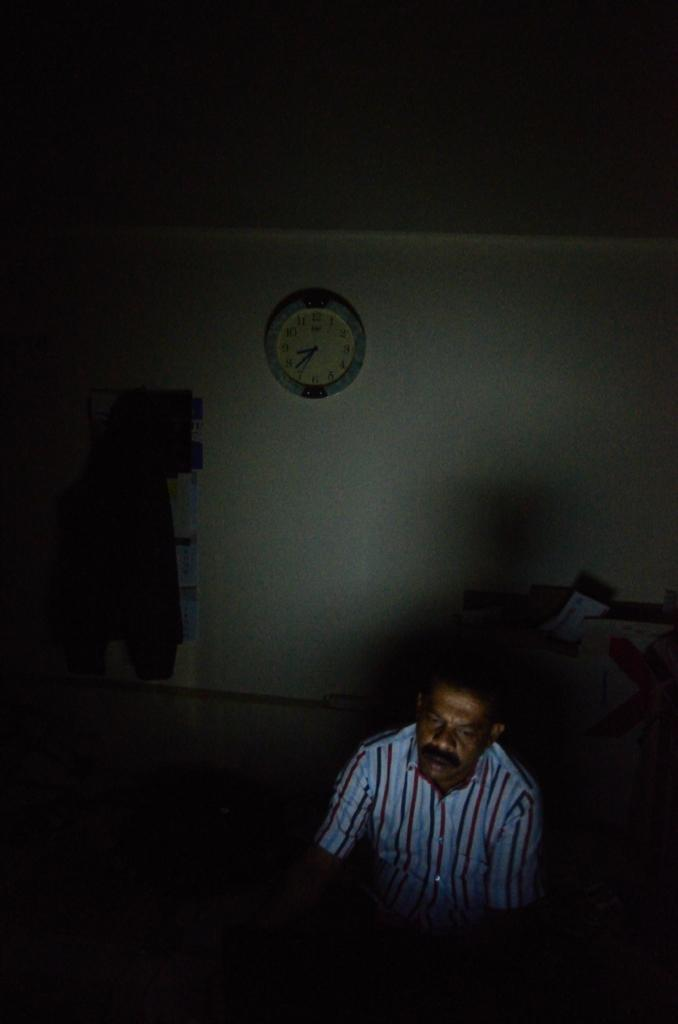Where was the image taken? The image was taken inside a room. What can be seen in the foreground of the image? There is a person in the foreground of the image. What is located in the middle of the image? There is a wall in the middle of the image. What is on the wall in the image? There is a clock on the wall. How would you describe the lighting in the top part of the image? The top part of the image is dark. How many books are stacked on the wound in the image? There are no books or wounds present in the image. 